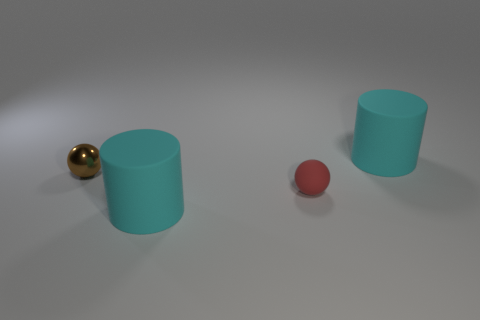Add 4 brown spheres. How many objects exist? 8 Add 1 large matte balls. How many large matte balls exist? 1 Subtract 0 red cylinders. How many objects are left? 4 Subtract all cyan matte cylinders. Subtract all small spheres. How many objects are left? 0 Add 4 tiny brown spheres. How many tiny brown spheres are left? 5 